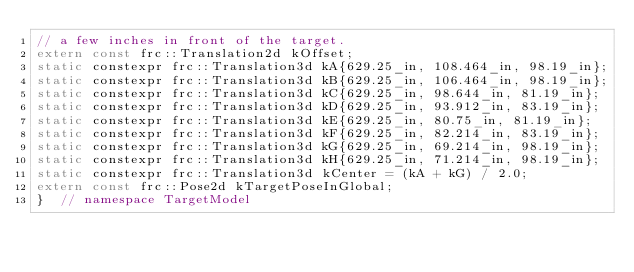Convert code to text. <code><loc_0><loc_0><loc_500><loc_500><_C++_>// a few inches in front of the target.
extern const frc::Translation2d kOffset;
static constexpr frc::Translation3d kA{629.25_in, 108.464_in, 98.19_in};
static constexpr frc::Translation3d kB{629.25_in, 106.464_in, 98.19_in};
static constexpr frc::Translation3d kC{629.25_in, 98.644_in, 81.19_in};
static constexpr frc::Translation3d kD{629.25_in, 93.912_in, 83.19_in};
static constexpr frc::Translation3d kE{629.25_in, 80.75_in, 81.19_in};
static constexpr frc::Translation3d kF{629.25_in, 82.214_in, 83.19_in};
static constexpr frc::Translation3d kG{629.25_in, 69.214_in, 98.19_in};
static constexpr frc::Translation3d kH{629.25_in, 71.214_in, 98.19_in};
static constexpr frc::Translation3d kCenter = (kA + kG) / 2.0;
extern const frc::Pose2d kTargetPoseInGlobal;
}  // namespace TargetModel
</code> 